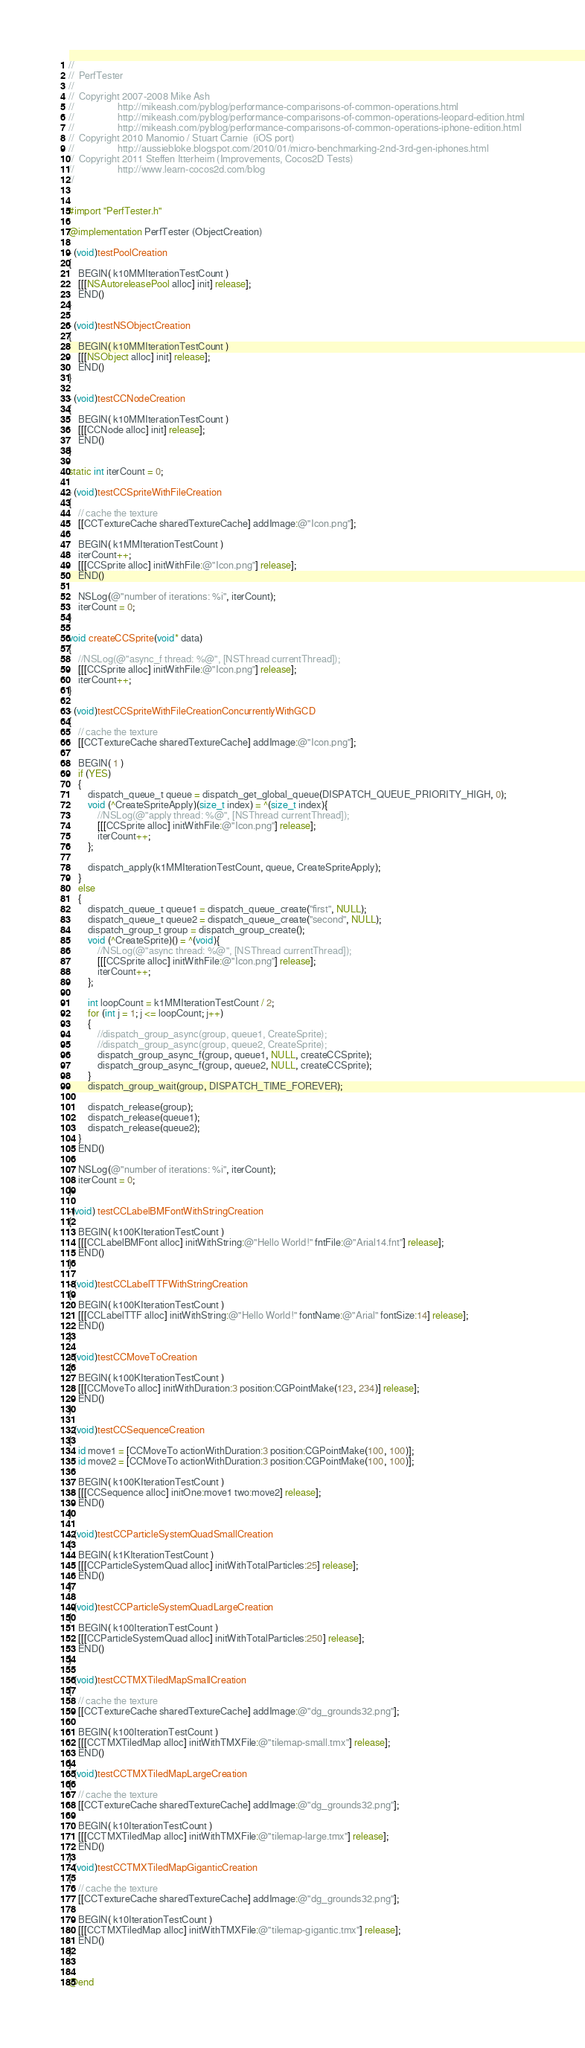<code> <loc_0><loc_0><loc_500><loc_500><_ObjectiveC_>//
//  PerfTester
//
//  Copyright 2007-2008 Mike Ash
//					http://mikeash.com/pyblog/performance-comparisons-of-common-operations.html
//					http://mikeash.com/pyblog/performance-comparisons-of-common-operations-leopard-edition.html
//					http://mikeash.com/pyblog/performance-comparisons-of-common-operations-iphone-edition.html
//	Copyright 2010 Manomio / Stuart Carnie  (iOS port)
//					http://aussiebloke.blogspot.com/2010/01/micro-benchmarking-2nd-3rd-gen-iphones.html
//	Copyright 2011 Steffen Itterheim (Improvements, Cocos2D Tests)
//					http://www.learn-cocos2d.com/blog
//


#import "PerfTester.h"

@implementation PerfTester (ObjectCreation)

- (void)testPoolCreation
{
    BEGIN( k10MMIterationTestCount )
	[[[NSAutoreleasePool alloc] init] release];
    END()
}

- (void)testNSObjectCreation
{
    BEGIN( k10MMIterationTestCount )
	[[[NSObject alloc] init] release];
    END()
}

- (void)testCCNodeCreation
{
    BEGIN( k10MMIterationTestCount )
	[[[CCNode alloc] init] release];
    END()
}

static int iterCount = 0;

- (void)testCCSpriteWithFileCreation
{
	// cache the texture
	[[CCTextureCache sharedTextureCache] addImage:@"Icon.png"];
	
    BEGIN( k1MMIterationTestCount )
	iterCount++;
	[[[CCSprite alloc] initWithFile:@"Icon.png"] release];
    END()
	
	NSLog(@"number of iterations: %i", iterCount);
	iterCount = 0;
}

void createCCSprite(void* data)
{
	//NSLog(@"async_f thread: %@", [NSThread currentThread]);
	[[[CCSprite alloc] initWithFile:@"Icon.png"] release];
	iterCount++;
}

- (void)testCCSpriteWithFileCreationConcurrentlyWithGCD
{
	// cache the texture
	[[CCTextureCache sharedTextureCache] addImage:@"Icon.png"];
	
    BEGIN( 1 )
	if (YES)
	{
		dispatch_queue_t queue = dispatch_get_global_queue(DISPATCH_QUEUE_PRIORITY_HIGH, 0);
		void (^CreateSpriteApply)(size_t index) = ^(size_t index){ 
			//NSLog(@"apply thread: %@", [NSThread currentThread]);
			[[[CCSprite alloc] initWithFile:@"Icon.png"] release]; 
			iterCount++;
		};
		
		dispatch_apply(k1MMIterationTestCount, queue, CreateSpriteApply);
	}
	else
	{
		dispatch_queue_t queue1 = dispatch_queue_create("first", NULL);
		dispatch_queue_t queue2 = dispatch_queue_create("second", NULL);
		dispatch_group_t group = dispatch_group_create();
		void (^CreateSprite)() = ^(void){
			//NSLog(@"async thread: %@", [NSThread currentThread]);
			[[[CCSprite alloc] initWithFile:@"Icon.png"] release];
			iterCount++;
		};
		
		int loopCount = k1MMIterationTestCount / 2;
		for (int j = 1; j <= loopCount; j++)
		{
			//dispatch_group_async(group, queue1, CreateSprite);
			//dispatch_group_async(group, queue2, CreateSprite);
			dispatch_group_async_f(group, queue1, NULL, createCCSprite);
			dispatch_group_async_f(group, queue2, NULL, createCCSprite);
		}
		dispatch_group_wait(group, DISPATCH_TIME_FOREVER);
		
		dispatch_release(group);
		dispatch_release(queue1);
		dispatch_release(queue2);
	}
    END()

	NSLog(@"number of iterations: %i", iterCount);
	iterCount = 0;
}

-(void) testCCLabelBMFontWithStringCreation
{
    BEGIN( k100KIterationTestCount )
	[[[CCLabelBMFont alloc] initWithString:@"Hello World!" fntFile:@"Arial14.fnt"] release];
    END()
}

- (void)testCCLabelTTFWithStringCreation
{
    BEGIN( k100KIterationTestCount )
	[[[CCLabelTTF alloc] initWithString:@"Hello World!" fontName:@"Arial" fontSize:14] release];
    END()
}

- (void)testCCMoveToCreation
{
    BEGIN( k100KIterationTestCount )
	[[[CCMoveTo alloc] initWithDuration:3 position:CGPointMake(123, 234)] release];
    END()
}

- (void)testCCSequenceCreation
{
	id move1 = [CCMoveTo actionWithDuration:3 position:CGPointMake(100, 100)];
	id move2 = [CCMoveTo actionWithDuration:3 position:CGPointMake(100, 100)];
	
    BEGIN( k100KIterationTestCount )
	[[[CCSequence alloc] initOne:move1 two:move2] release];
    END()
}

- (void)testCCParticleSystemQuadSmallCreation
{
    BEGIN( k1KIterationTestCount )
	[[[CCParticleSystemQuad alloc] initWithTotalParticles:25] release];
    END()
}

- (void)testCCParticleSystemQuadLargeCreation
{
    BEGIN( k100IterationTestCount )
	[[[CCParticleSystemQuad alloc] initWithTotalParticles:250] release];
    END()
}

- (void)testCCTMXTiledMapSmallCreation
{
	// cache the texture
	[[CCTextureCache sharedTextureCache] addImage:@"dg_grounds32.png"];

    BEGIN( k100IterationTestCount )
	[[[CCTMXTiledMap alloc] initWithTMXFile:@"tilemap-small.tmx"] release];
    END()
}
- (void)testCCTMXTiledMapLargeCreation
{
	// cache the texture
	[[CCTextureCache sharedTextureCache] addImage:@"dg_grounds32.png"];
	
    BEGIN( k10IterationTestCount )
	[[[CCTMXTiledMap alloc] initWithTMXFile:@"tilemap-large.tmx"] release];
    END()
}
- (void)testCCTMXTiledMapGiganticCreation
{
	// cache the texture
	[[CCTextureCache sharedTextureCache] addImage:@"dg_grounds32.png"];
	
    BEGIN( k10IterationTestCount )
	[[[CCTMXTiledMap alloc] initWithTMXFile:@"tilemap-gigantic.tmx"] release];
    END()
}


@end
</code> 